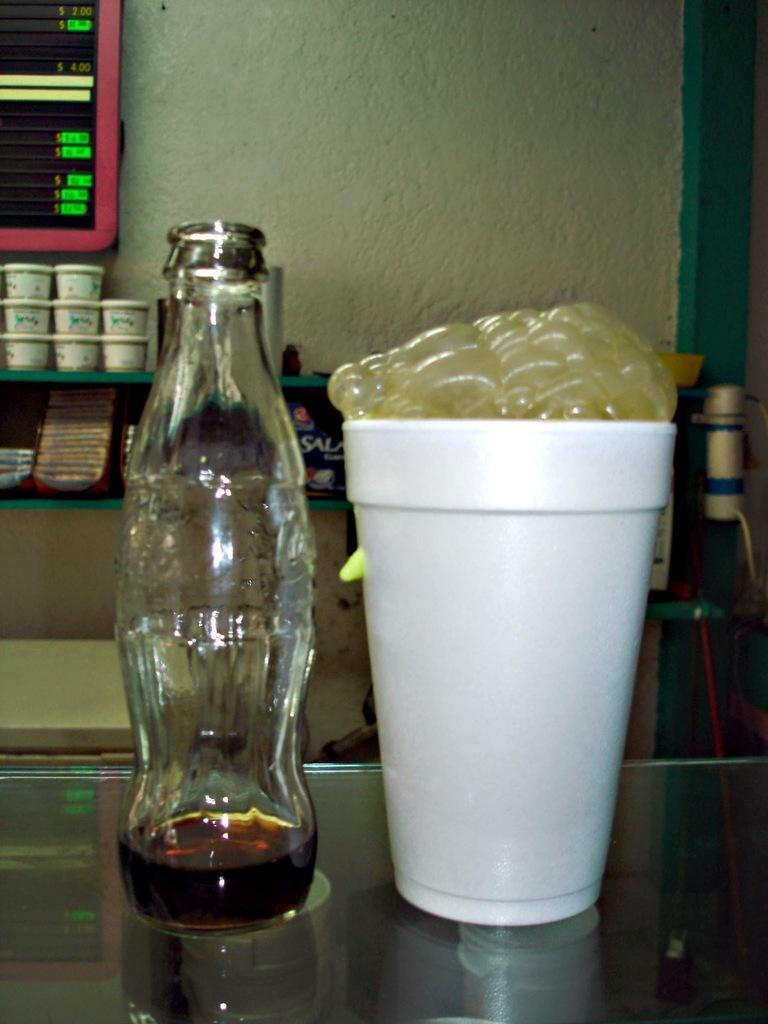What objects are on the table in the image? There is a bottle and a cup on the table in the image. Can you describe the objects in the background of the image? There are boxes in the background of the image. What type of harmony can be heard in the image? There is no audible sound or music in the image, so it is not possible to determine if there is any harmony present. 